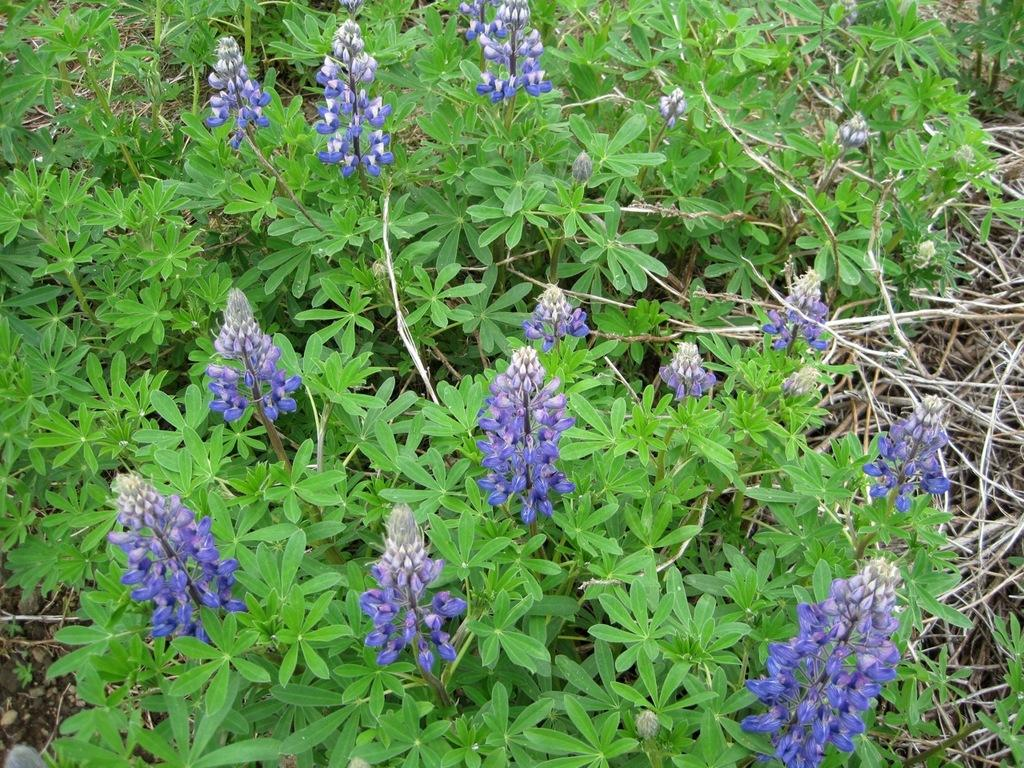What type of flowers can be seen in the image? There are violet color flowers in the image. What other elements are present in the image besides the flowers? There are plants and twigs in the image. Where are these elements located in the image? These elements are located on the right side of the image. Can you see a toothbrush being used on the cabbage in the image? There is no toothbrush or cabbage present in the image. 